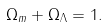Convert formula to latex. <formula><loc_0><loc_0><loc_500><loc_500>\Omega _ { m } + \Omega _ { \Lambda } = 1 .</formula> 